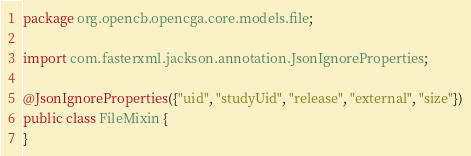<code> <loc_0><loc_0><loc_500><loc_500><_Java_>package org.opencb.opencga.core.models.file;

import com.fasterxml.jackson.annotation.JsonIgnoreProperties;

@JsonIgnoreProperties({"uid", "studyUid", "release", "external", "size"})
public class FileMixin {
}
</code> 